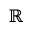Convert formula to latex. <formula><loc_0><loc_0><loc_500><loc_500>\mathbb { R }</formula> 